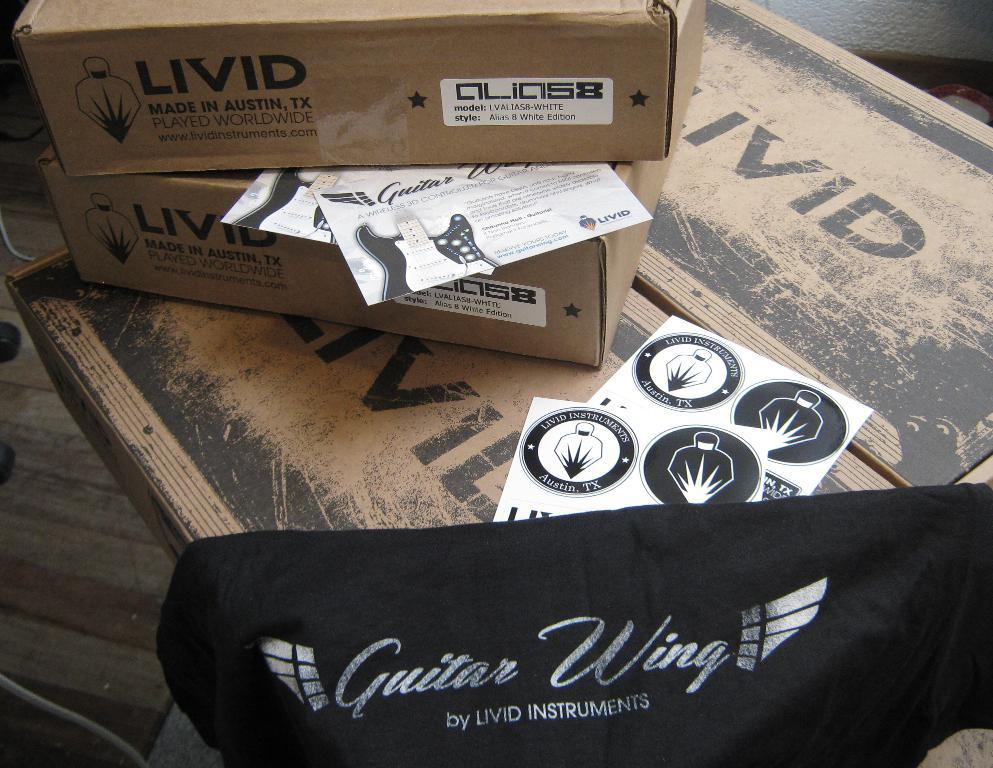What objects are on the table in the image? There are two cardboard boxes, two pages, and a black color cloth on the table. What is the color of the table in the image? The table is in brown color. How many fingers can be seen pointing at the pen in the image? There is no pen present in the image, so it is not possible to determine how many fingers might be pointing at it. 